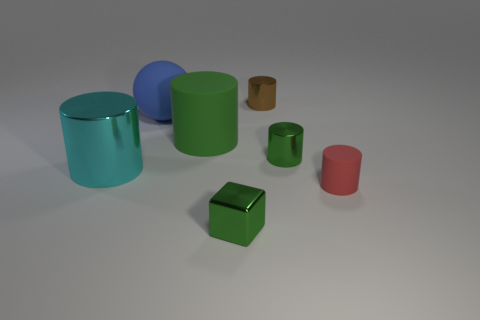How many big cylinders have the same color as the shiny cube?
Your response must be concise. 1. What color is the large ball that is made of the same material as the red thing?
Your answer should be very brief. Blue. Are there any brown metallic cylinders that have the same size as the red object?
Your response must be concise. Yes. Is the number of things behind the cyan shiny thing greater than the number of large shiny cylinders behind the tiny green shiny cylinder?
Your answer should be compact. Yes. Does the tiny green thing that is in front of the small red thing have the same material as the tiny red cylinder on the right side of the small green metallic cylinder?
Make the answer very short. No. What shape is the blue rubber thing that is the same size as the cyan cylinder?
Give a very brief answer. Sphere. Is there a small brown thing that has the same shape as the tiny red thing?
Ensure brevity in your answer.  Yes. Is the color of the shiny thing that is in front of the red rubber cylinder the same as the tiny metal cylinder in front of the big blue matte ball?
Give a very brief answer. Yes. There is a tiny cube; are there any tiny red things on the left side of it?
Make the answer very short. No. What is the small cylinder that is both in front of the brown object and on the left side of the red cylinder made of?
Offer a very short reply. Metal. 